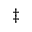<formula> <loc_0><loc_0><loc_500><loc_500>^ { \ddag }</formula> 